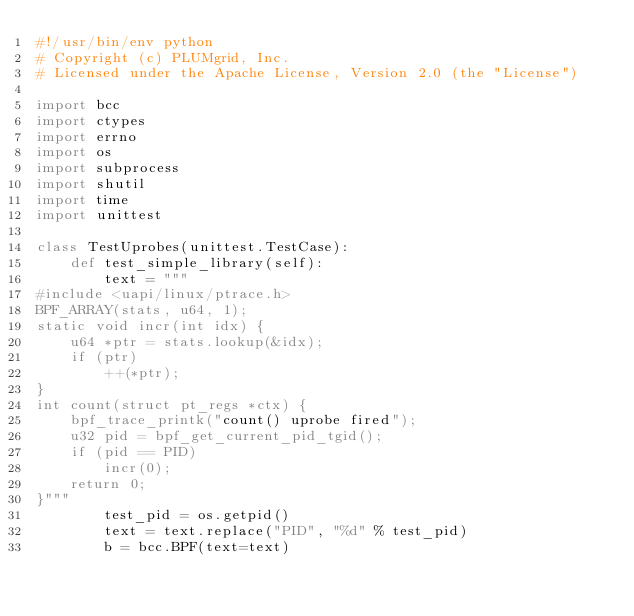Convert code to text. <code><loc_0><loc_0><loc_500><loc_500><_Python_>#!/usr/bin/env python
# Copyright (c) PLUMgrid, Inc.
# Licensed under the Apache License, Version 2.0 (the "License")

import bcc
import ctypes
import errno
import os
import subprocess
import shutil
import time
import unittest

class TestUprobes(unittest.TestCase):
    def test_simple_library(self):
        text = """
#include <uapi/linux/ptrace.h>
BPF_ARRAY(stats, u64, 1);
static void incr(int idx) {
    u64 *ptr = stats.lookup(&idx);
    if (ptr)
        ++(*ptr);
}
int count(struct pt_regs *ctx) {
    bpf_trace_printk("count() uprobe fired");
    u32 pid = bpf_get_current_pid_tgid();
    if (pid == PID)
        incr(0);
    return 0;
}"""
        test_pid = os.getpid()
        text = text.replace("PID", "%d" % test_pid)
        b = bcc.BPF(text=text)</code> 